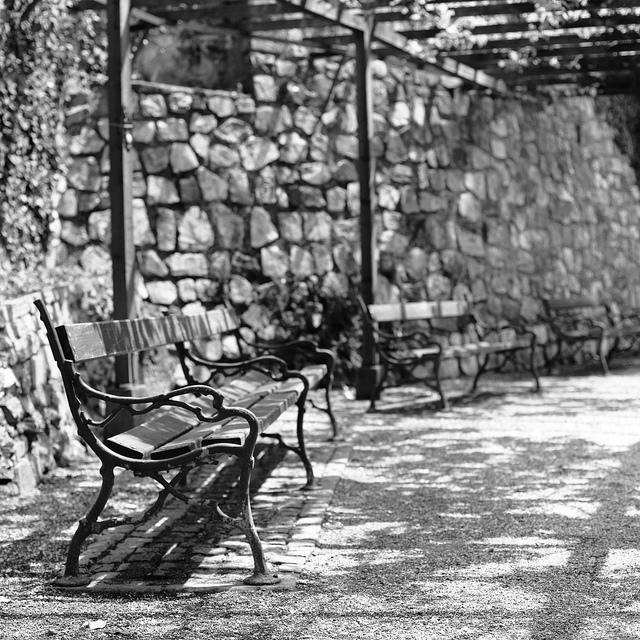What is the material of the wall?
Write a very short answer. Stone. Why is sunlight able to shine down into this area?
Give a very brief answer. Outside. Is the photo black and white?
Write a very short answer. Yes. 